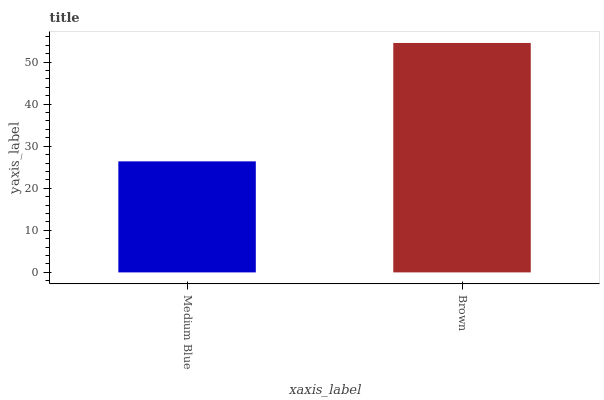Is Medium Blue the minimum?
Answer yes or no. Yes. Is Brown the maximum?
Answer yes or no. Yes. Is Brown the minimum?
Answer yes or no. No. Is Brown greater than Medium Blue?
Answer yes or no. Yes. Is Medium Blue less than Brown?
Answer yes or no. Yes. Is Medium Blue greater than Brown?
Answer yes or no. No. Is Brown less than Medium Blue?
Answer yes or no. No. Is Brown the high median?
Answer yes or no. Yes. Is Medium Blue the low median?
Answer yes or no. Yes. Is Medium Blue the high median?
Answer yes or no. No. Is Brown the low median?
Answer yes or no. No. 